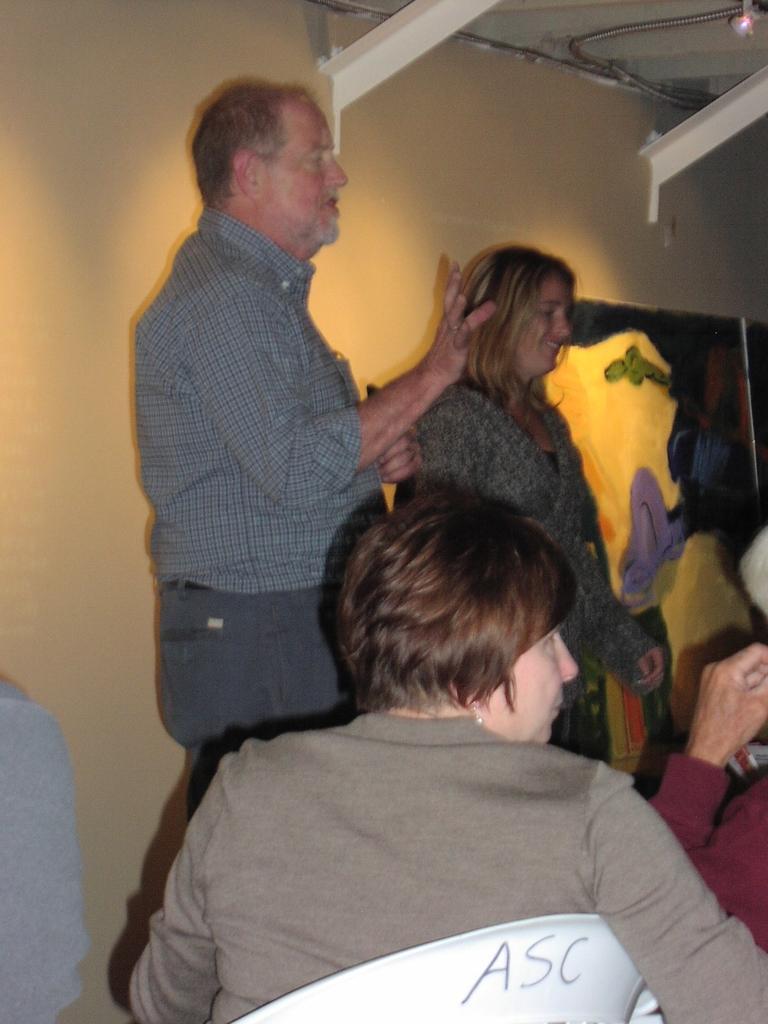Could you give a brief overview of what you see in this image? In this picture I can see a man and woman standing and few people seated on the chairs and I can see painting on the wall. 